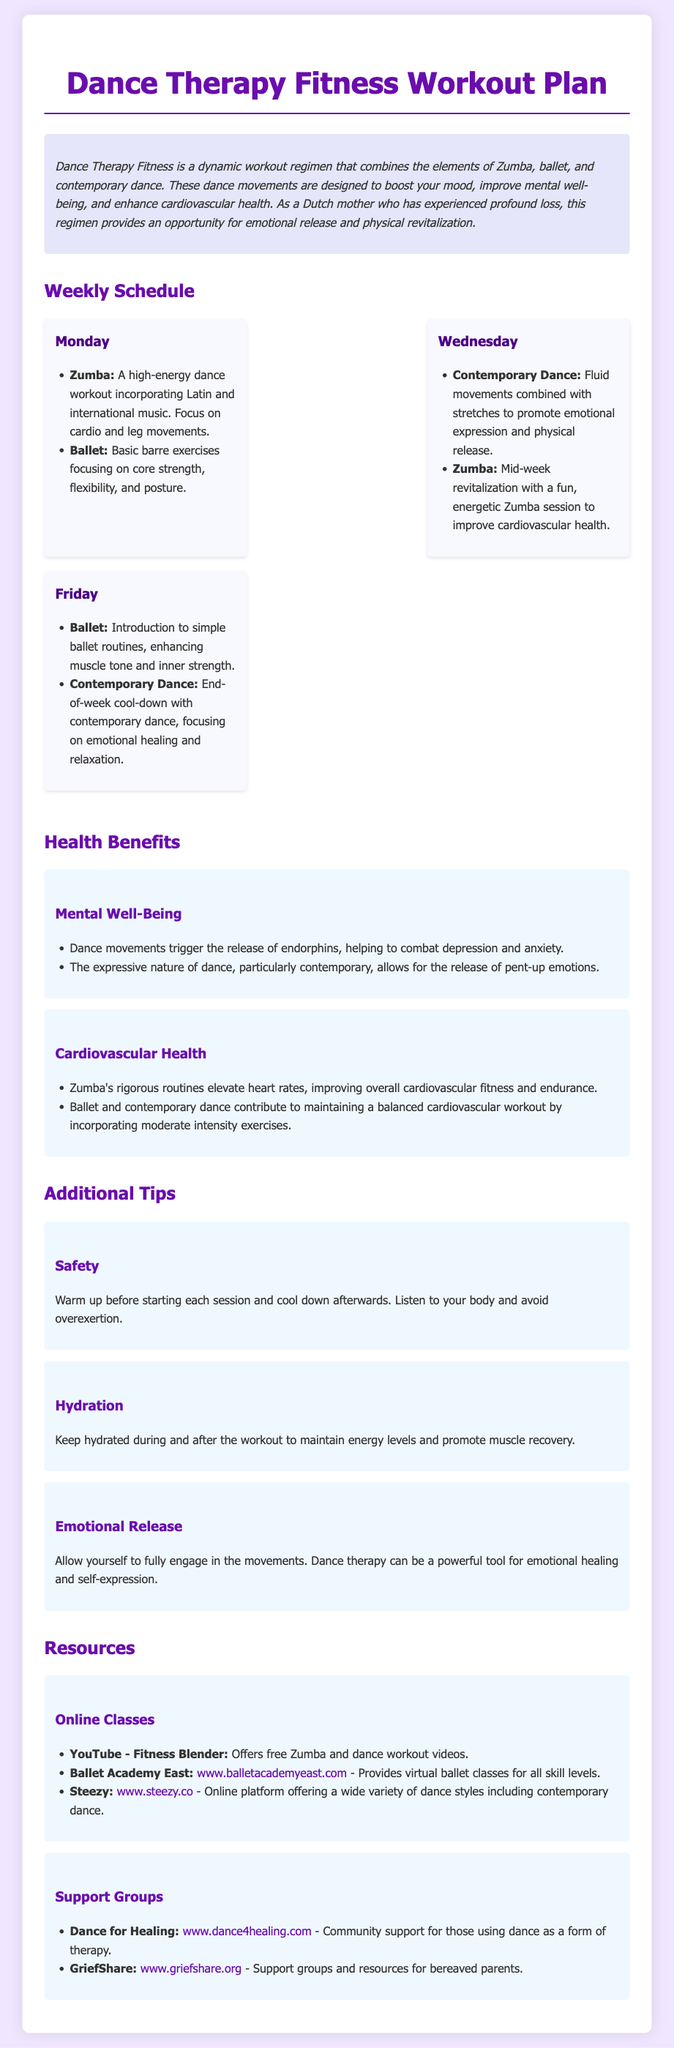What dance styles are included in the Dance Therapy Fitness program? The document lists Zumba, ballet, and contemporary dance as the dance styles included in the program.
Answer: Zumba, ballet, contemporary dance How many days a week is the Dance Therapy Fitness regimen scheduled? The document outlines a workout plan for three days, which are Monday, Wednesday, and Friday.
Answer: Three days What is emphasized in the Zumba session on Monday? The Zumba session on Monday emphasizes cardio and leg movements as part of the workout.
Answer: Cardio and leg movements What emotional benefit does contemporary dance provide according to the document? The document states that contemporary dance promotes emotional expression and physical release.
Answer: Emotional expression and physical release What should participants remember regarding hydration? The document advises participants to keep hydrated during and after the workout to maintain energy levels and promote muscle recovery.
Answer: Keep hydrated How does Zumba contribute to cardiovascular health? The document explains that Zumba's rigorous routines elevate heart rates, improving overall cardiovascular fitness and endurance.
Answer: Elevate heart rates What is the primary focus of ballet routines introduced on Friday? The ballet routines introduced on Friday focus on enhancing muscle tone and inner strength.
Answer: Enhancing muscle tone and inner strength Where can one find online ballet classes according to the resources section? The resource section mentions Ballet Academy East as a provider of virtual ballet classes for all skill levels.
Answer: Ballet Academy East Which website offers community support for those using dance as therapy? The document mentions the website Dance for Healing as providing community support for individuals using dance as therapy.
Answer: Dance for Healing 